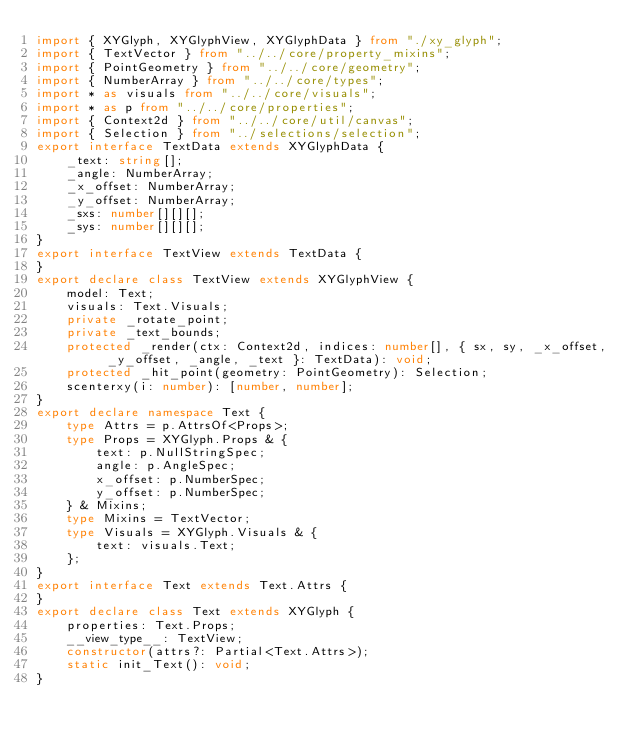Convert code to text. <code><loc_0><loc_0><loc_500><loc_500><_TypeScript_>import { XYGlyph, XYGlyphView, XYGlyphData } from "./xy_glyph";
import { TextVector } from "../../core/property_mixins";
import { PointGeometry } from "../../core/geometry";
import { NumberArray } from "../../core/types";
import * as visuals from "../../core/visuals";
import * as p from "../../core/properties";
import { Context2d } from "../../core/util/canvas";
import { Selection } from "../selections/selection";
export interface TextData extends XYGlyphData {
    _text: string[];
    _angle: NumberArray;
    _x_offset: NumberArray;
    _y_offset: NumberArray;
    _sxs: number[][][];
    _sys: number[][][];
}
export interface TextView extends TextData {
}
export declare class TextView extends XYGlyphView {
    model: Text;
    visuals: Text.Visuals;
    private _rotate_point;
    private _text_bounds;
    protected _render(ctx: Context2d, indices: number[], { sx, sy, _x_offset, _y_offset, _angle, _text }: TextData): void;
    protected _hit_point(geometry: PointGeometry): Selection;
    scenterxy(i: number): [number, number];
}
export declare namespace Text {
    type Attrs = p.AttrsOf<Props>;
    type Props = XYGlyph.Props & {
        text: p.NullStringSpec;
        angle: p.AngleSpec;
        x_offset: p.NumberSpec;
        y_offset: p.NumberSpec;
    } & Mixins;
    type Mixins = TextVector;
    type Visuals = XYGlyph.Visuals & {
        text: visuals.Text;
    };
}
export interface Text extends Text.Attrs {
}
export declare class Text extends XYGlyph {
    properties: Text.Props;
    __view_type__: TextView;
    constructor(attrs?: Partial<Text.Attrs>);
    static init_Text(): void;
}
</code> 